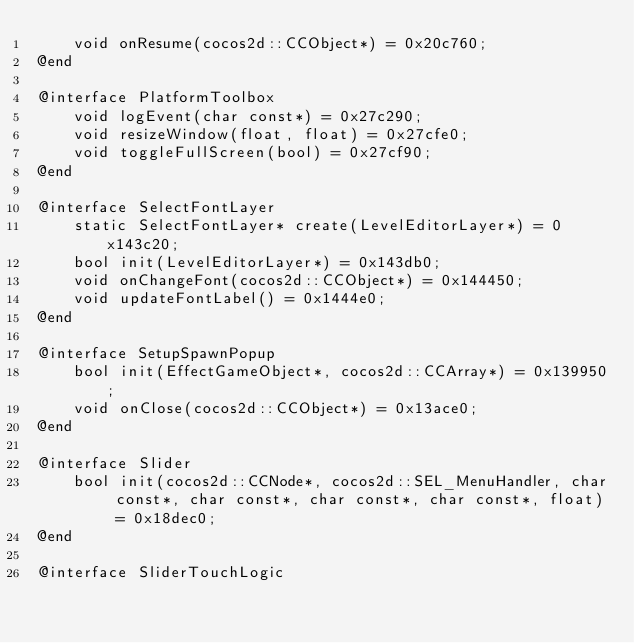<code> <loc_0><loc_0><loc_500><loc_500><_ObjectiveC_>    void onResume(cocos2d::CCObject*) = 0x20c760;
@end

@interface PlatformToolbox
    void logEvent(char const*) = 0x27c290;
    void resizeWindow(float, float) = 0x27cfe0;
    void toggleFullScreen(bool) = 0x27cf90;
@end

@interface SelectFontLayer
    static SelectFontLayer* create(LevelEditorLayer*) = 0x143c20;
    bool init(LevelEditorLayer*) = 0x143db0;
    void onChangeFont(cocos2d::CCObject*) = 0x144450;
    void updateFontLabel() = 0x1444e0;
@end

@interface SetupSpawnPopup
    bool init(EffectGameObject*, cocos2d::CCArray*) = 0x139950;
    void onClose(cocos2d::CCObject*) = 0x13ace0;
@end

@interface Slider
    bool init(cocos2d::CCNode*, cocos2d::SEL_MenuHandler, char const*, char const*, char const*, char const*, float) = 0x18dec0;
@end

@interface SliderTouchLogic</code> 